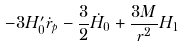Convert formula to latex. <formula><loc_0><loc_0><loc_500><loc_500>- 3 H ^ { \prime } _ { 0 } \dot { r } _ { p } - \frac { 3 } { 2 } { \dot { H } } _ { 0 } + \frac { 3 M } { r ^ { 2 } } H _ { 1 }</formula> 